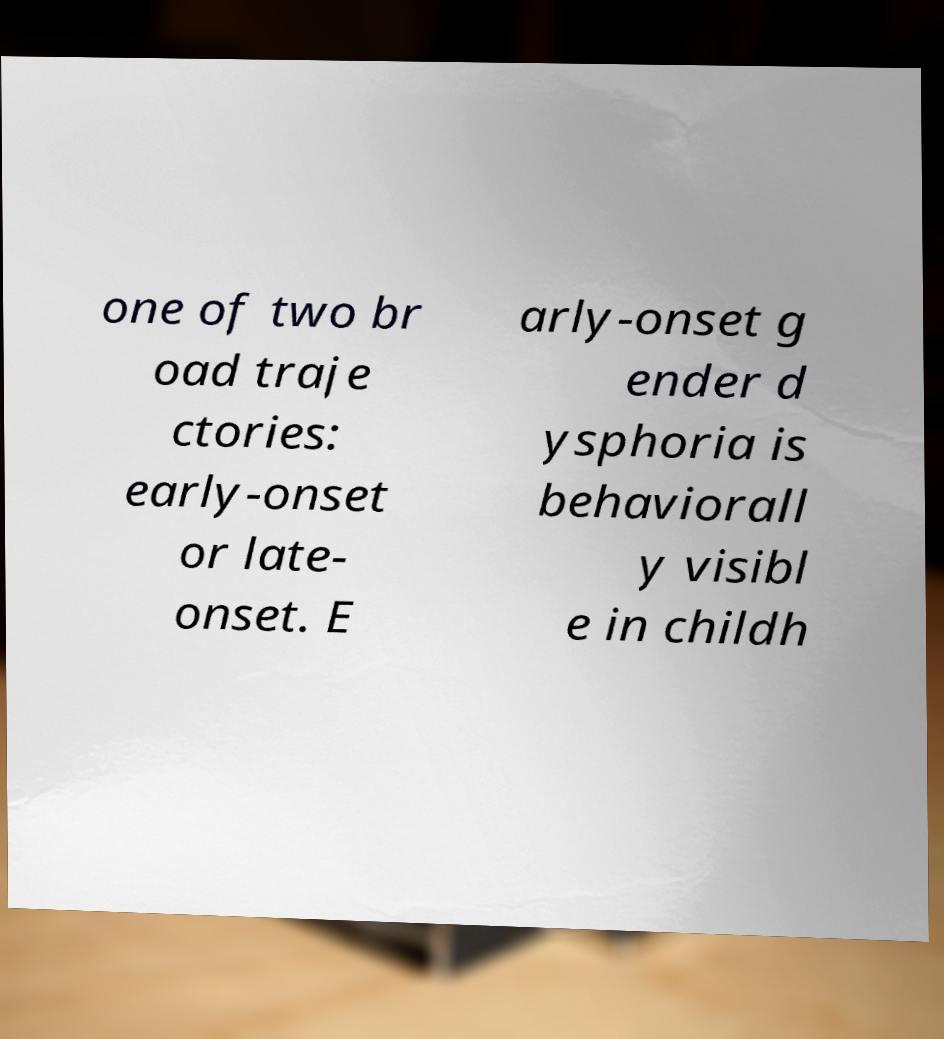Please read and relay the text visible in this image. What does it say? one of two br oad traje ctories: early-onset or late- onset. E arly-onset g ender d ysphoria is behaviorall y visibl e in childh 